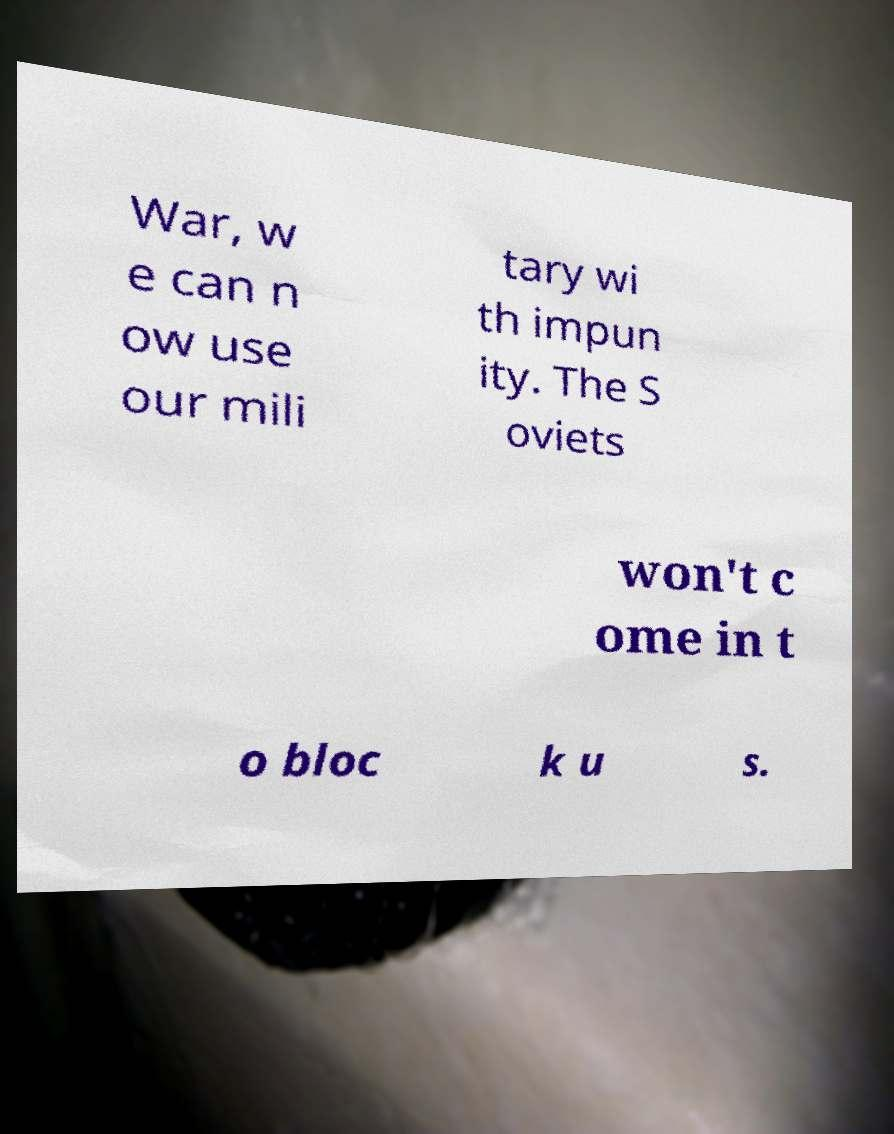Can you accurately transcribe the text from the provided image for me? War, w e can n ow use our mili tary wi th impun ity. The S oviets won't c ome in t o bloc k u s. 